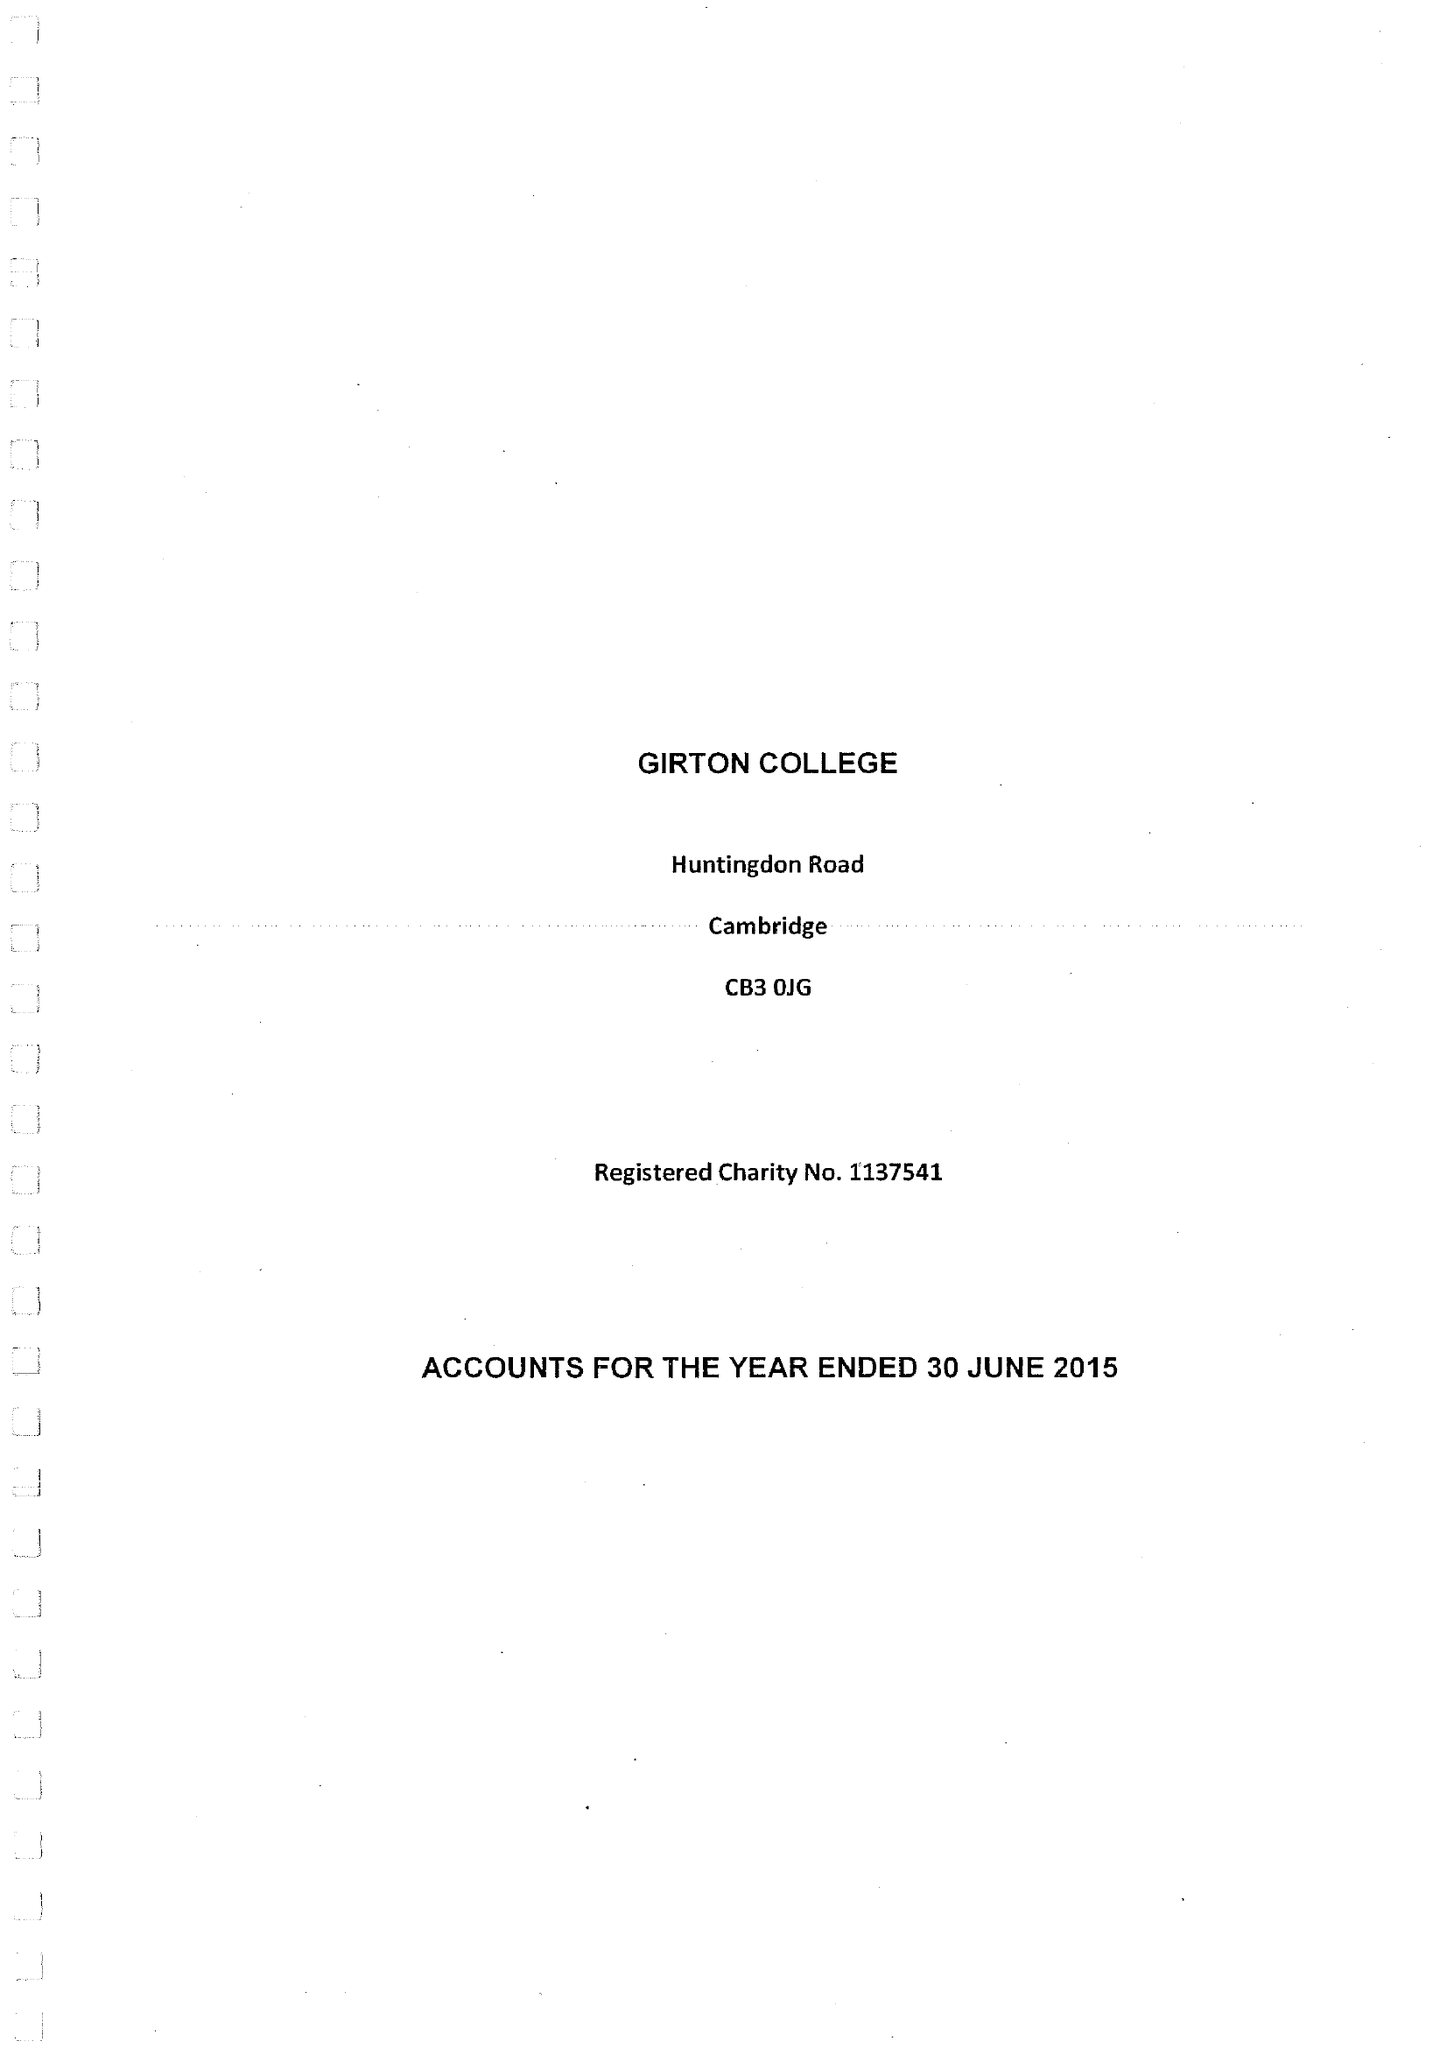What is the value for the address__street_line?
Answer the question using a single word or phrase. HUNTINGDON ROAD 